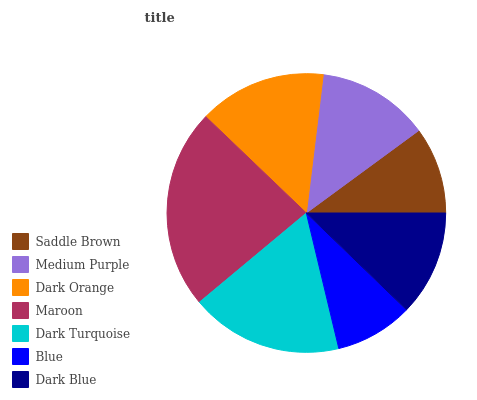Is Blue the minimum?
Answer yes or no. Yes. Is Maroon the maximum?
Answer yes or no. Yes. Is Medium Purple the minimum?
Answer yes or no. No. Is Medium Purple the maximum?
Answer yes or no. No. Is Medium Purple greater than Saddle Brown?
Answer yes or no. Yes. Is Saddle Brown less than Medium Purple?
Answer yes or no. Yes. Is Saddle Brown greater than Medium Purple?
Answer yes or no. No. Is Medium Purple less than Saddle Brown?
Answer yes or no. No. Is Medium Purple the high median?
Answer yes or no. Yes. Is Medium Purple the low median?
Answer yes or no. Yes. Is Dark Orange the high median?
Answer yes or no. No. Is Maroon the low median?
Answer yes or no. No. 